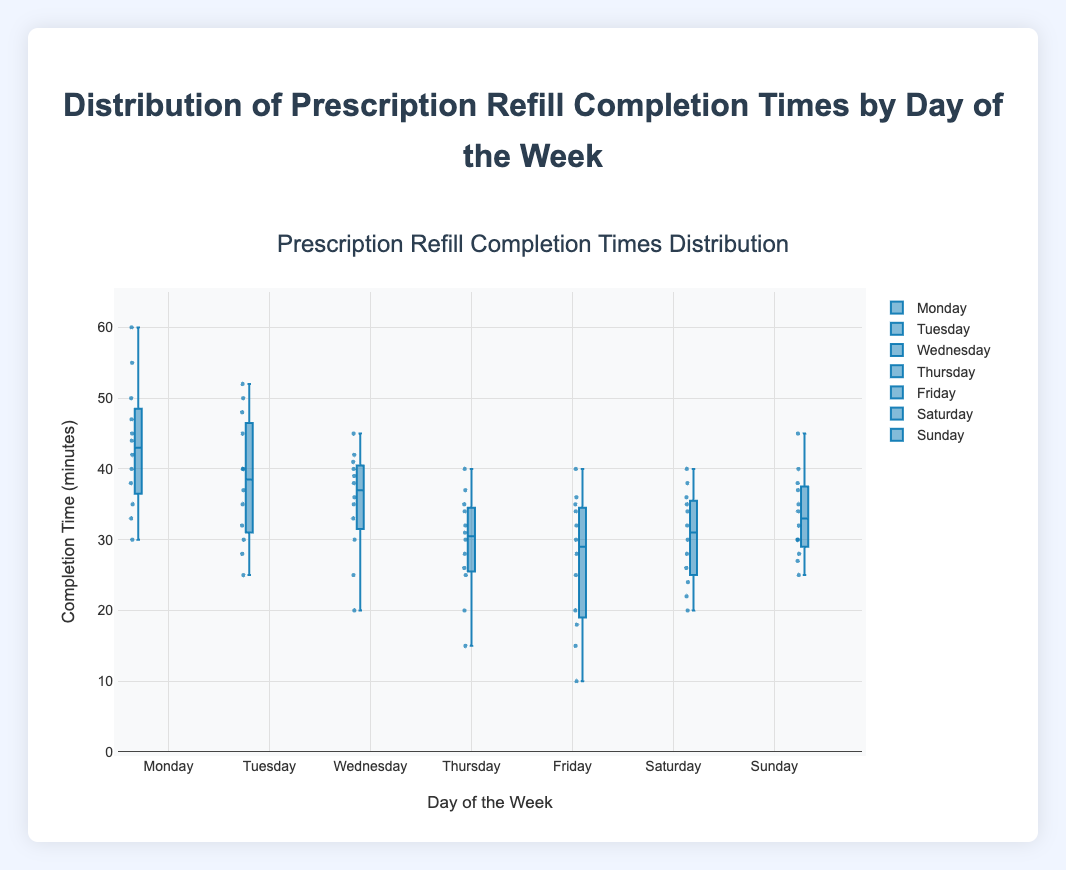What is the range of prescription refill completion times on Monday? The range is calculated by subtracting the minimum value from the maximum value for Monday's data. The minimum value is 30 and the maximum value is 60, so the range is 60 - 30 = 30 minutes.
Answer: 30 minutes What day has the highest median completion time for prescription refills? By looking at the central line inside the box plots, Sunday has the highest median completion time compared to other days.
Answer: Sunday How does the distribution of completion times on Friday compare to Monday? By comparing the box plots for Friday and Monday, Friday's interquartile range (IQR) is smaller, and the values generally appear lower compared to Monday's.
Answer: Friday's values are generally lower and have a smaller IQR than Monday's Which day has the widest interquartile range (IQR) for completion times? The IQR is the distance between the first quartile (Q1) and the third quartile (Q3). By looking at the box plots, Monday has the largest IQR as the box is the longest.
Answer: Monday Is there any day with outliers in the completion times? Outliers are marked as individual points outside of the whiskers in a box plot. By inspecting the plots, no explicit outliers are visible for any day.
Answer: No What is the median completion time on Thursday? The median is represented by the central line within the box. For Thursday, the median completion time is approximately 30 minutes.
Answer: 30 minutes Which day shows the lowest median completion time? By comparing the central lines of the boxes, Friday has the lowest median completion time.
Answer: Friday On which day is the highest completion time recorded? The highest completion time is the topmost value of the whisker or individual point. For Monday, the highest recorded time is 60 minutes.
Answer: Monday Is there a day where completion times are consistently low? Consistently low times would show a lower range and lower median. Friday has both the lowest median and smaller range of values compared to other days.
Answer: Friday What is the interquartile range (IQR) for Wednesday? The IQR is found by subtracting Q1 from Q3. On Wednesday, Q1 is approximately 30 and Q3 is approximately 40, so the IQR is 40 - 30 = 10 minutes.
Answer: 10 minutes 